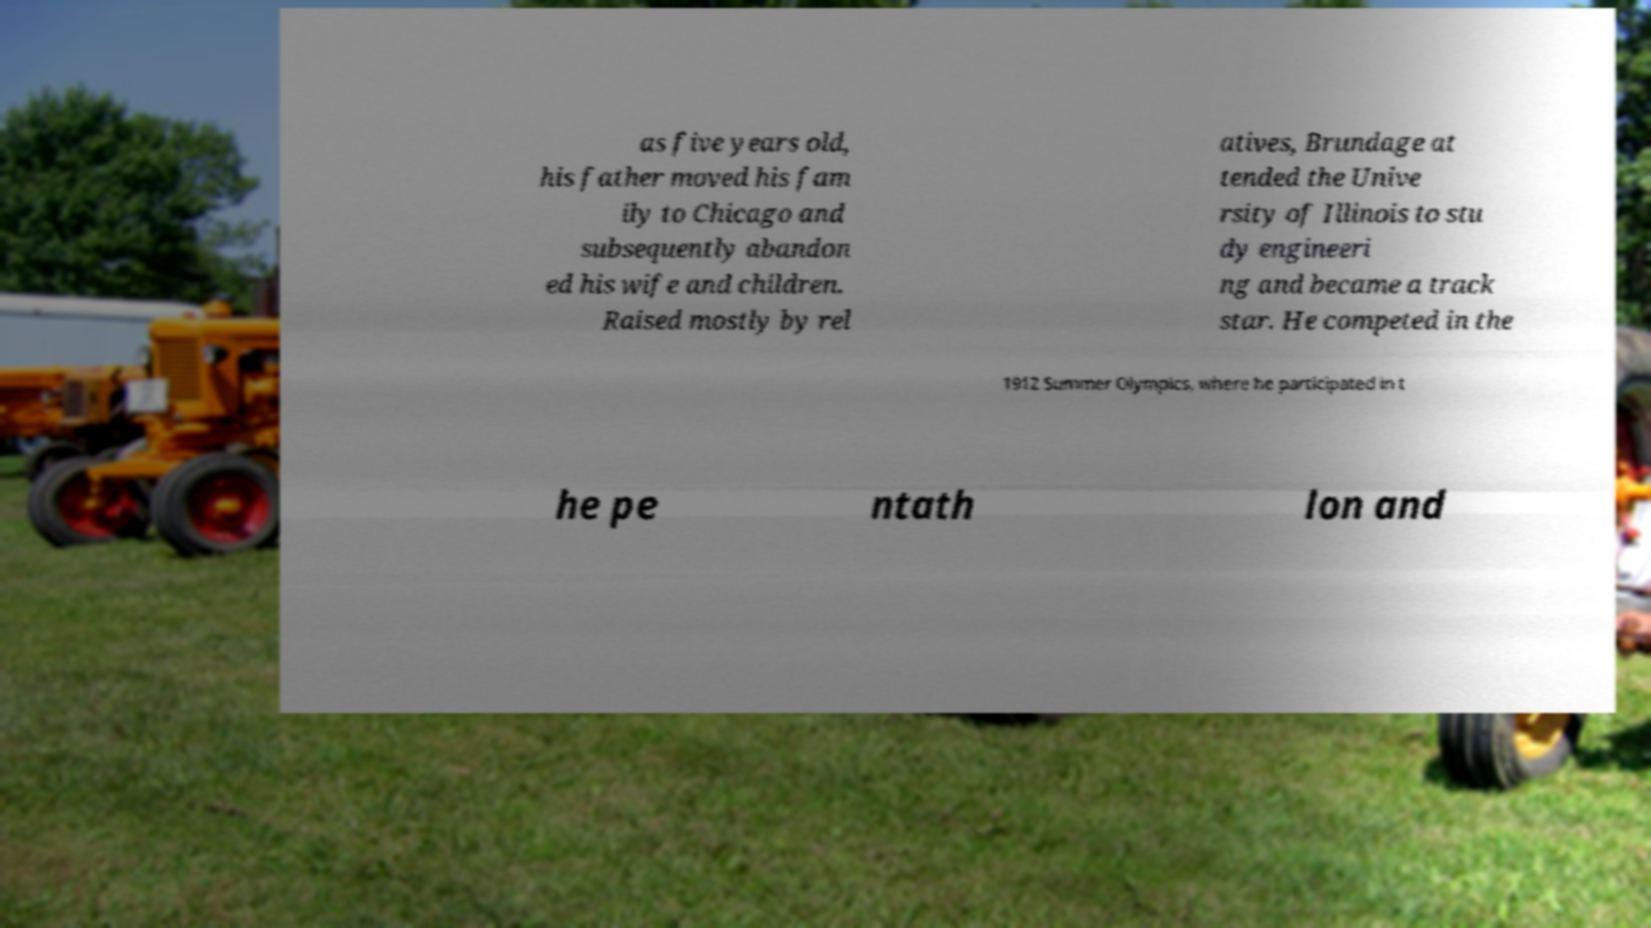What messages or text are displayed in this image? I need them in a readable, typed format. as five years old, his father moved his fam ily to Chicago and subsequently abandon ed his wife and children. Raised mostly by rel atives, Brundage at tended the Unive rsity of Illinois to stu dy engineeri ng and became a track star. He competed in the 1912 Summer Olympics, where he participated in t he pe ntath lon and 